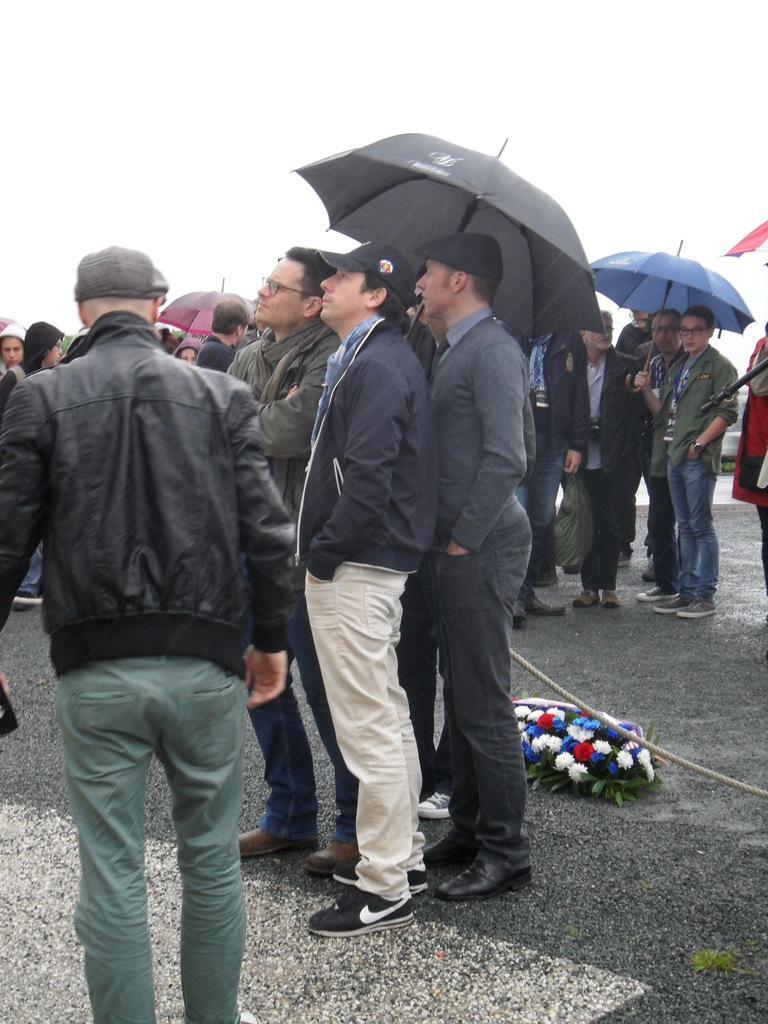Please provide a concise description of this image. In this picture we can see a group of people standing on the road, rope, flowers, leaves, umbrellas and in the background we can see the sky. 